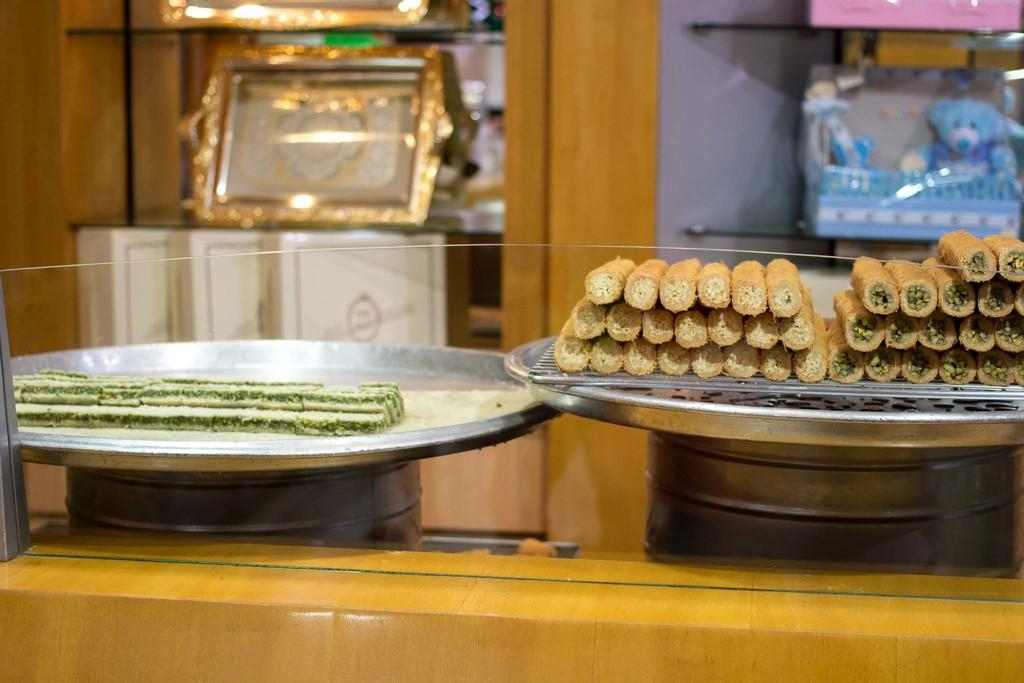What can be found on the plates in the image? There are food items on the plates in the image. What are the plates placed on? There are objects on which the plates are placed. What materials can be seen at the bottom of the image? There are glass and wood elements at the bottom of the image. What type of storage is visible in the image? There are shelves with objects in the image. Can you see a plane flying in the image? There is no plane visible in the image. What type of flesh can be seen on the plates in the image? There is no flesh present on the plates in the image; it is food items, not flesh. 